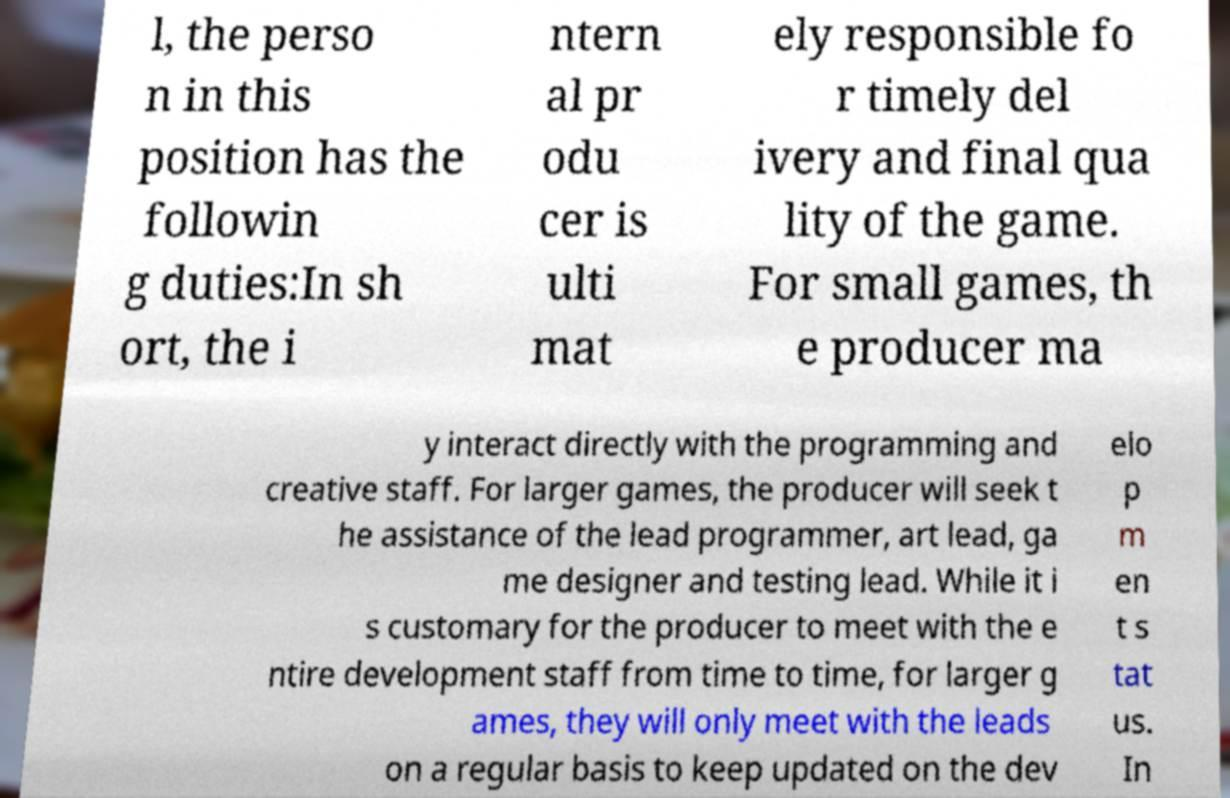Please read and relay the text visible in this image. What does it say? l, the perso n in this position has the followin g duties:In sh ort, the i ntern al pr odu cer is ulti mat ely responsible fo r timely del ivery and final qua lity of the game. For small games, th e producer ma y interact directly with the programming and creative staff. For larger games, the producer will seek t he assistance of the lead programmer, art lead, ga me designer and testing lead. While it i s customary for the producer to meet with the e ntire development staff from time to time, for larger g ames, they will only meet with the leads on a regular basis to keep updated on the dev elo p m en t s tat us. In 